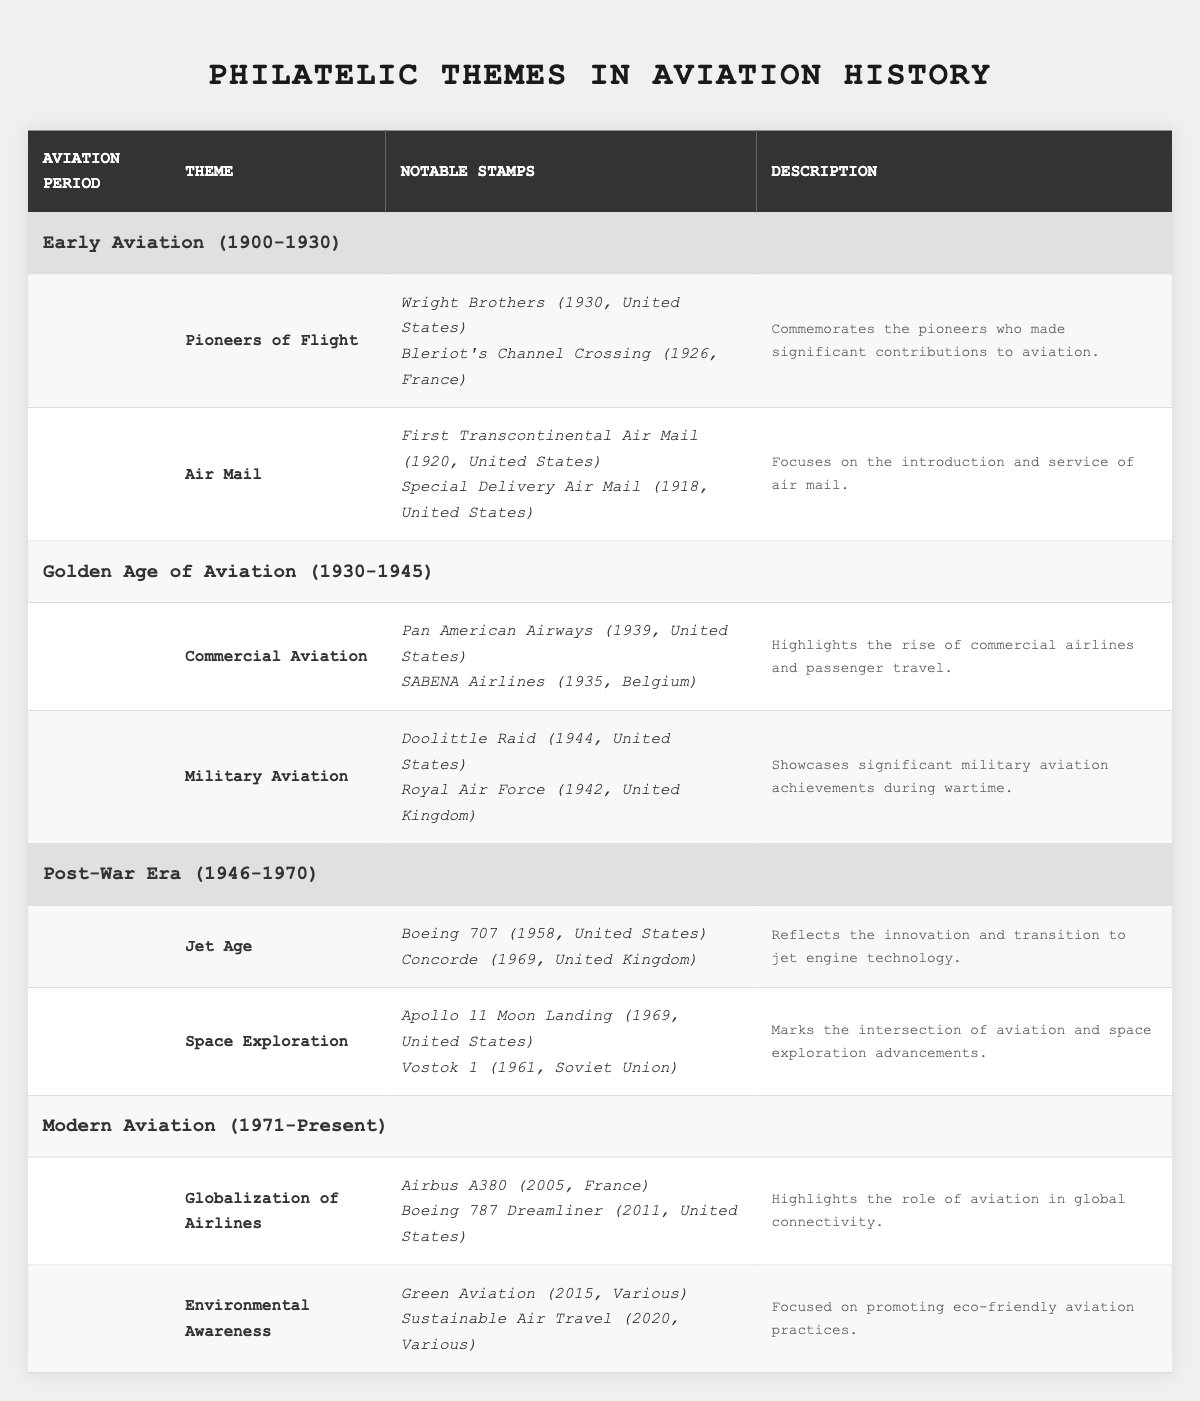What themes are associated with the Early Aviation period? The Early Aviation period covers two themes: "Pioneers of Flight" and "Air Mail." These themes can be directly found in the table under the Early Aviation section.
Answer: Pioneers of Flight, Air Mail How many notable stamps are listed under the Golden Age of Aviation theme "Commercial Aviation"? Under the theme "Commercial Aviation," there are two notable stamps: "Pan American Airways" and "SABENA Airlines," which can be counted directly from the table.
Answer: 2 Is there a theme related to space exploration in the table? Yes, the table includes a theme titled "Space Exploration" under the Post-War Era section. This confirms the presence of a theme concerning space exploration.
Answer: Yes Which aviation period has the theme "Environmental Awareness"? The theme "Environmental Awareness" is found under the Modern Aviation period. This can be confirmed by looking at the respective section in the table.
Answer: Modern Aviation (1971-Present) What is the earliest year of a notable stamp in the "Air Mail" theme? The earliest year for a notable stamp in the "Air Mail" theme is 1918, which corresponds to the "Special Delivery Air Mail" stamp. This information can be found by examining the years of notable stamps listed under that theme.
Answer: 1918 If I compare the total number of notable stamps between the "Jet Age" and "Globalization of Airlines" themes, which has more stamps? Both themes have two notable stamps each ("Jet Age" has Boeing 707 and Concorde, "Globalization of Airlines" has Airbus A380 and Boeing 787 Dreamliner), thus they are equal. This can be verified by totaling the notable stamps listed under both themes.
Answer: They are equal In which countries were stamps from the theme "Pioneers of Flight" issued? The theme "Pioneers of Flight" includes noticeable stamps issued in the United States and France, as those countries are listed next to the respective notable stamps in the table.
Answer: United States, France Which aviation period features stamps commemorating the Apollo 11 Moon Landing? The Apollo 11 Moon Landing is commemorated in the Post-War Era (1946-1970) under the "Space Exploration" theme, which can be confirmed from the table's period specified for that stamp.
Answer: Post-War Era (1946-1970) What can you conclude about the progression of aviation themes from Early Aviation to Modern Aviation? As seen in the table, the themes progress from pioneering flights and air mail in early aviation to commercial aviation and environmental awareness in modern times, indicating the evolution of aviation technology and its impact on society.
Answer: Evolution of themes indicates technological advancements in aviation Are there any notable stamps from the Soviet Union listed in the table? Yes, there is one notable stamp from the Soviet Union listed, which is "Vostok 1" from 1961, found under the "Space Exploration" theme in the Post-War Era section.
Answer: Yes, Vostok 1 (1961) 